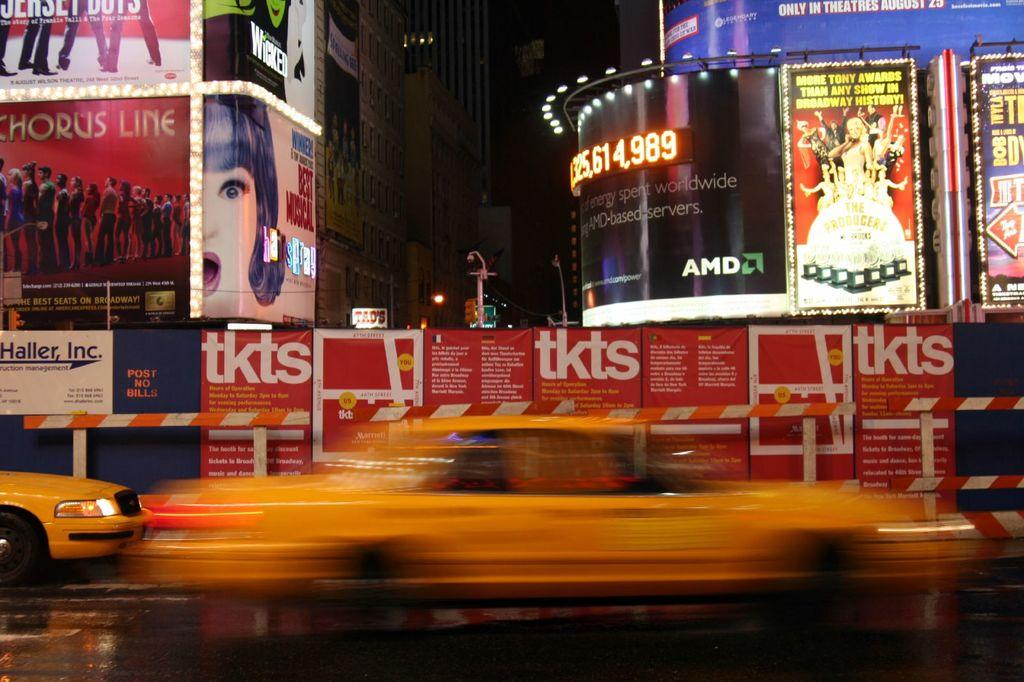<image>
Render a clear and concise summary of the photo. street billboards for plays like the producers and the jersey boys 